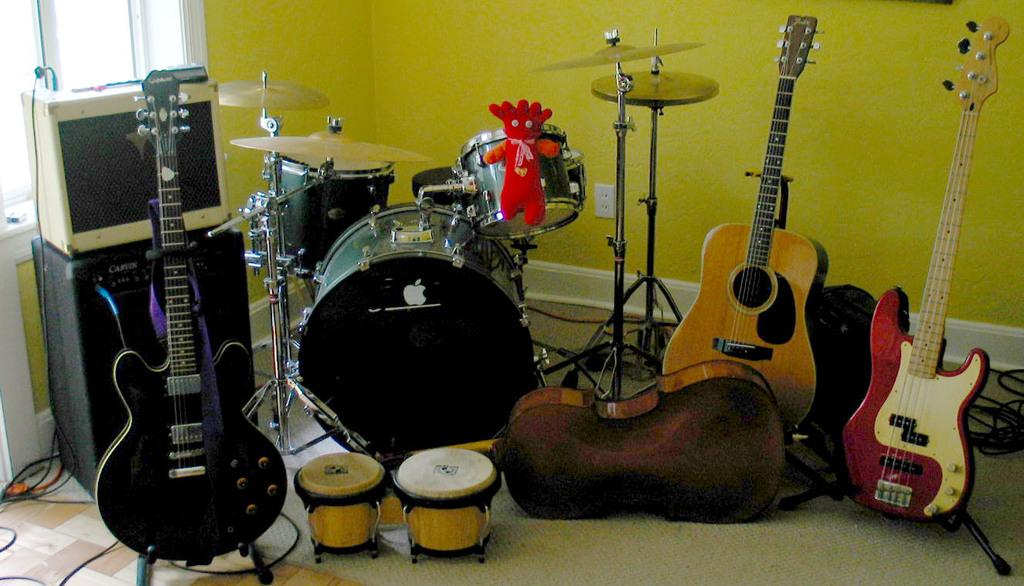What musical instruments can be seen in the image? There is a guitar and a drum in the image, which are both musical instruments. What is the color of the wall in the image? The wall is yellow in the image. What is the purpose of the plate in the image? The plate is also a musical instrument, likely used as a percussion instrument. What is the doll doing in the image? The doll is attached to a drum in the image. What part of the instruments might amplify sound? There are sound boxes in the image, which might amplify sound from the instruments. Can you see any fish swimming in the image? No, there are no fish present in the image. What type of rail is used to hold the guitar in the image? There is no rail present in the image; the guitar is resting on a surface. 